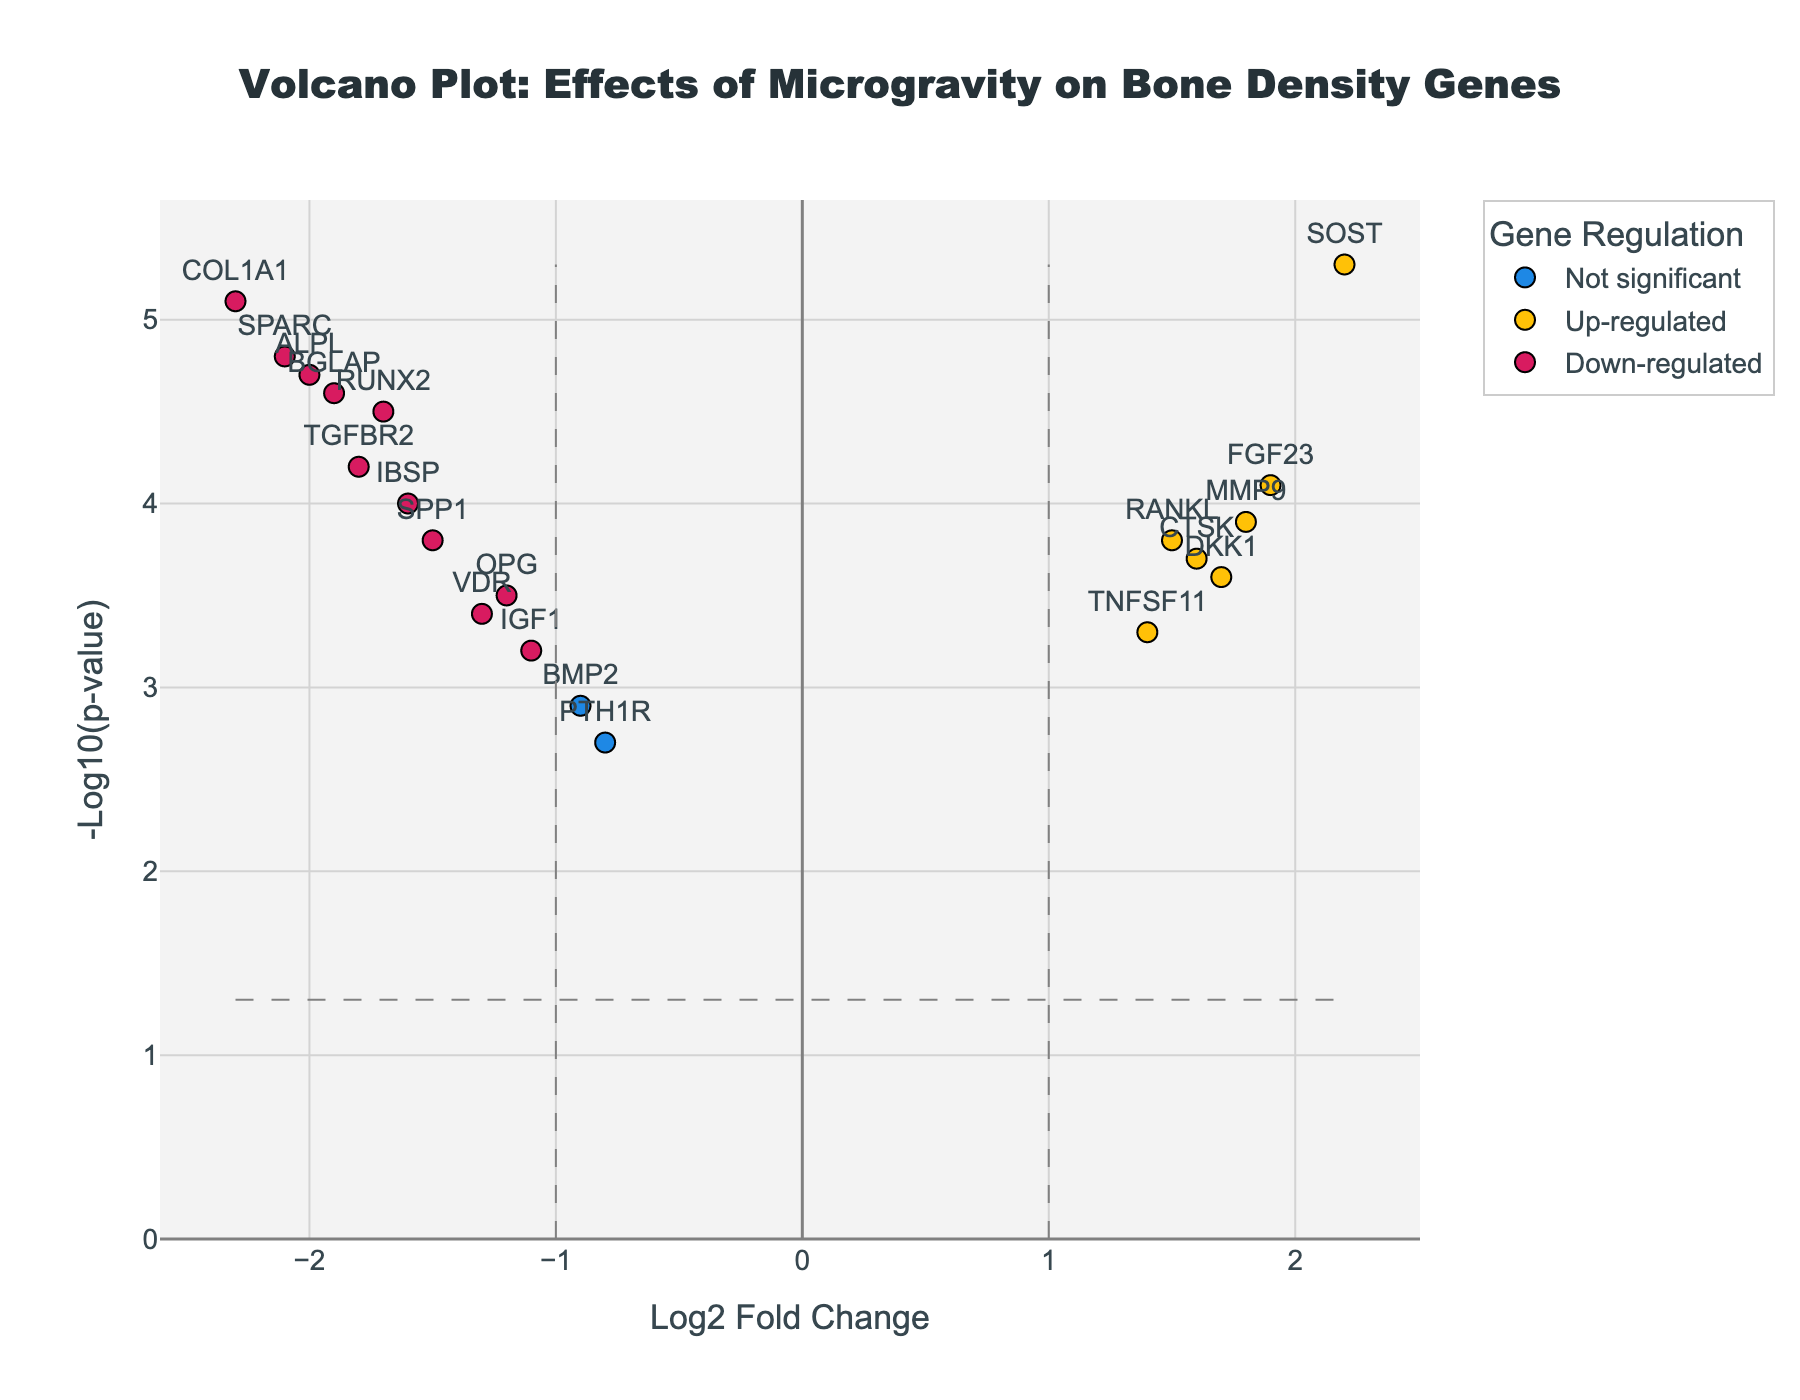What's the title of the Volcano Plot? The title of the plot is usually displayed prominently at the top center of the figure. In this case, it reads "Volcano Plot: Effects of Microgravity on Bone Density Genes".
Answer: Volcano Plot: Effects of Microgravity on Bone Density Genes What are the x-axis and y-axis labels? The x-axis and y-axis labels are typically indicated near the axis lines. Here, the x-axis is labeled "Log2 Fold Change" and the y-axis is labeled "-Log10(p-value)".
Answer: Log2 Fold Change, -Log10(p-value) How many genes are classified as 'Up-regulated'? To determine the number of 'Up-regulated' genes, we look at the data points in the plot's legend. Each category has a different color or marker style. We count the points in the 'Up-regulated' category.
Answer: 5 Which gene has the highest -Log10(p-value)? This information can be observed by finding the gene with the highest vertical position on the plot, as the y-axis represents -Log10(p-value).
Answer: SOST Which gene has the lowest Log2 Fold Change? The lowest Log2 Fold Change corresponds to the leftmost point on the x-axis of the plot. We identify the gene label at that point.
Answer: COL1A1 Compare and list the genes that are 'Up-regulated' and 'Down-regulated'. We distinguish between 'Up-regulated' and 'Down-regulated' categories by their respective colors or markers and list the genes accordingly. 'Up-regulated' genes (right side of the plot) are RANKL, MMP9, SOST, CTSK, FGF23, and DKK1, while 'Down-regulated' genes (left side of the plot) are TGFBR2, COL1A1, OPG, RUNX2, SPARC, BGLAP, IGF1, VDR, ALPL, IBSP, and SPP1.
Answer: Up-regulated: RANKL, MMP9, SOST, CTSK, FGF23, DKK1; Down-regulated: TGFBR2, COL1A1, OPG, RUNX2, SPARC, BGLAP, IGF1, VDR, ALPL, IBSP, SPP1 What are the Log2 Fold Change and -Log10(p-value) for the gene BGLAP? We locate the gene BGLAP in the plot and refer to its coordinates on the x and y axes, respectively. The values are visible in the hover text or marked position.
Answer: -1.9, 4.6 Which genes fall into the 'Not significant' category? Genes in the 'Not significant' category do not exceed the defined significance thresholds and are visualized with a unique color or marker. Examine the plot legend and count these points.
Answer: BMP2, PTH1R, TNFSF11 What is the range of -Log10(p-value) for the genes in the plot? The range of -Log10(p-value) can be determined by identifying the minimum and maximum values on the y-axis, observing the highest and lowest points on the plot.
Answer: 2.7 to 5.3 How does the fold change of the gene RUNX2 compare to that of the gene MMP9? We look at the position of RUNX2 and MMP9 along the x-axis. RUNX2 has a Log2 Fold Change of -1.7, and MMP9 has a Log2 Fold Change of 1.8. Compare their values directly.
Answer: RUNX2: -1.7, MMP9: 1.8 